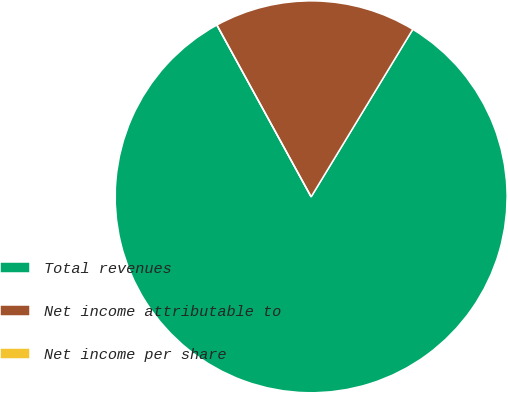Convert chart to OTSL. <chart><loc_0><loc_0><loc_500><loc_500><pie_chart><fcel>Total revenues<fcel>Net income attributable to<fcel>Net income per share<nl><fcel>83.33%<fcel>16.67%<fcel>0.0%<nl></chart> 